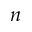<formula> <loc_0><loc_0><loc_500><loc_500>n</formula> 